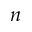<formula> <loc_0><loc_0><loc_500><loc_500>n</formula> 